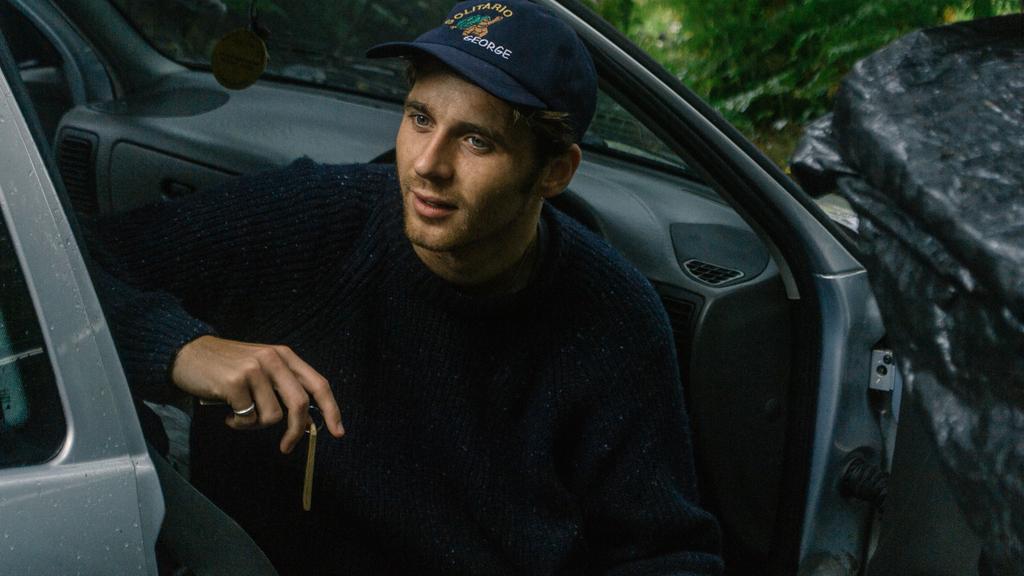Can you describe this image briefly? here we can see the person sitting in the car holding the keys.. 